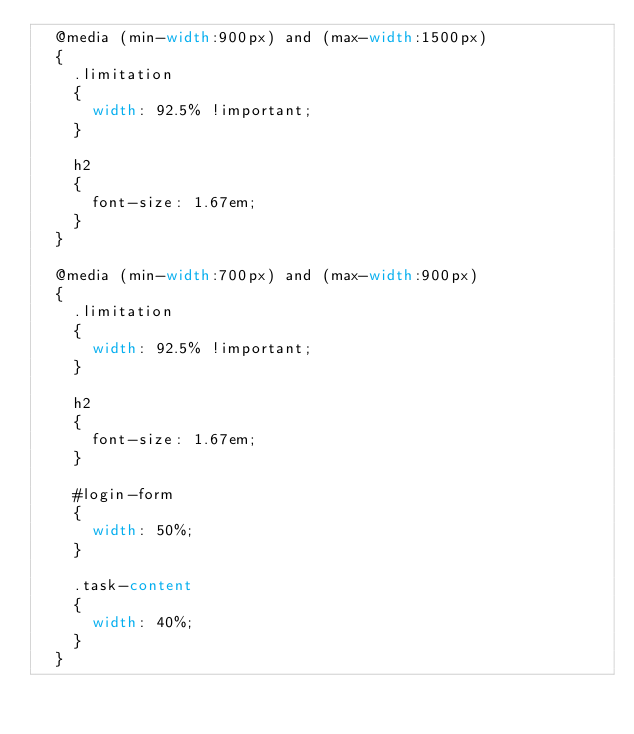<code> <loc_0><loc_0><loc_500><loc_500><_CSS_>  @media (min-width:900px) and (max-width:1500px)
  {
    .limitation
    {
      width: 92.5% !important;
    }

    h2
    {
      font-size: 1.67em;
    }
  }

  @media (min-width:700px) and (max-width:900px)
  {
    .limitation
    {
      width: 92.5% !important;
    }

    h2
    {
      font-size: 1.67em;
    }

    #login-form
    {
      width: 50%;
    }
    
    .task-content
    {
      width: 40%;
    }
  }
</code> 